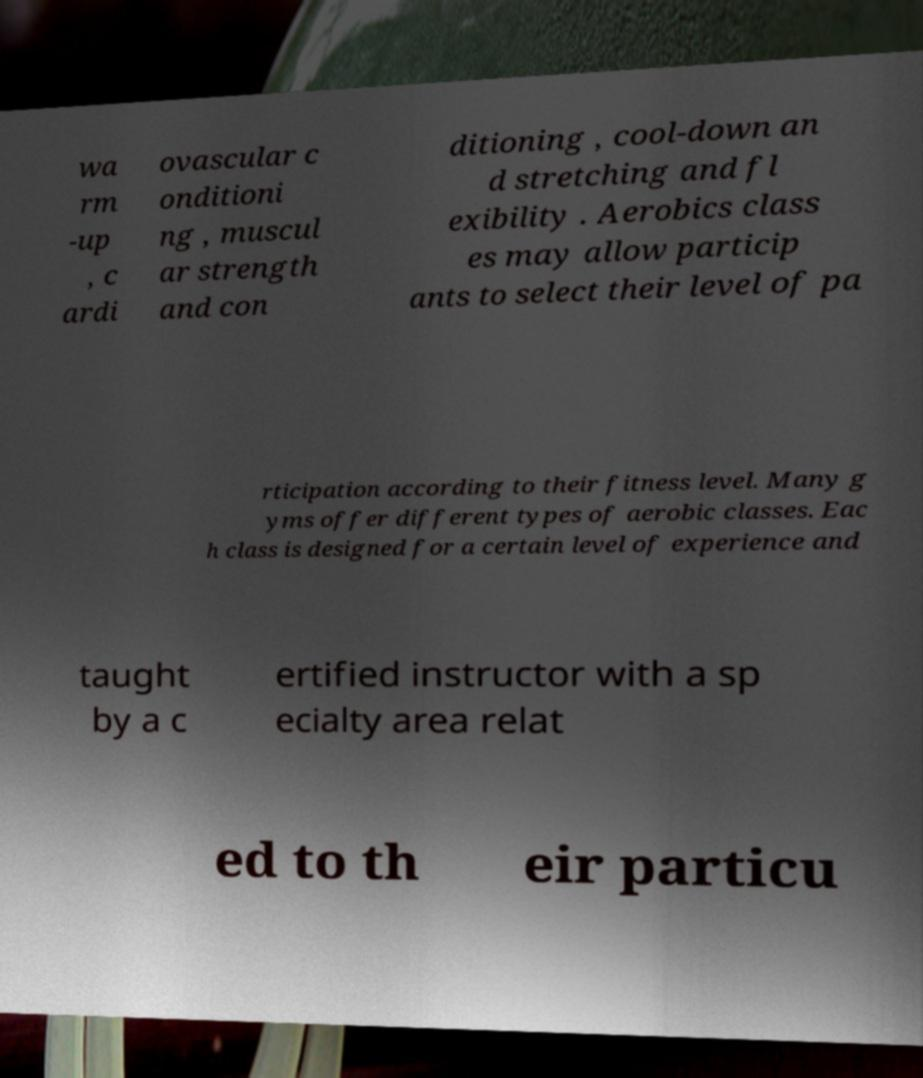I need the written content from this picture converted into text. Can you do that? wa rm -up , c ardi ovascular c onditioni ng , muscul ar strength and con ditioning , cool-down an d stretching and fl exibility . Aerobics class es may allow particip ants to select their level of pa rticipation according to their fitness level. Many g yms offer different types of aerobic classes. Eac h class is designed for a certain level of experience and taught by a c ertified instructor with a sp ecialty area relat ed to th eir particu 